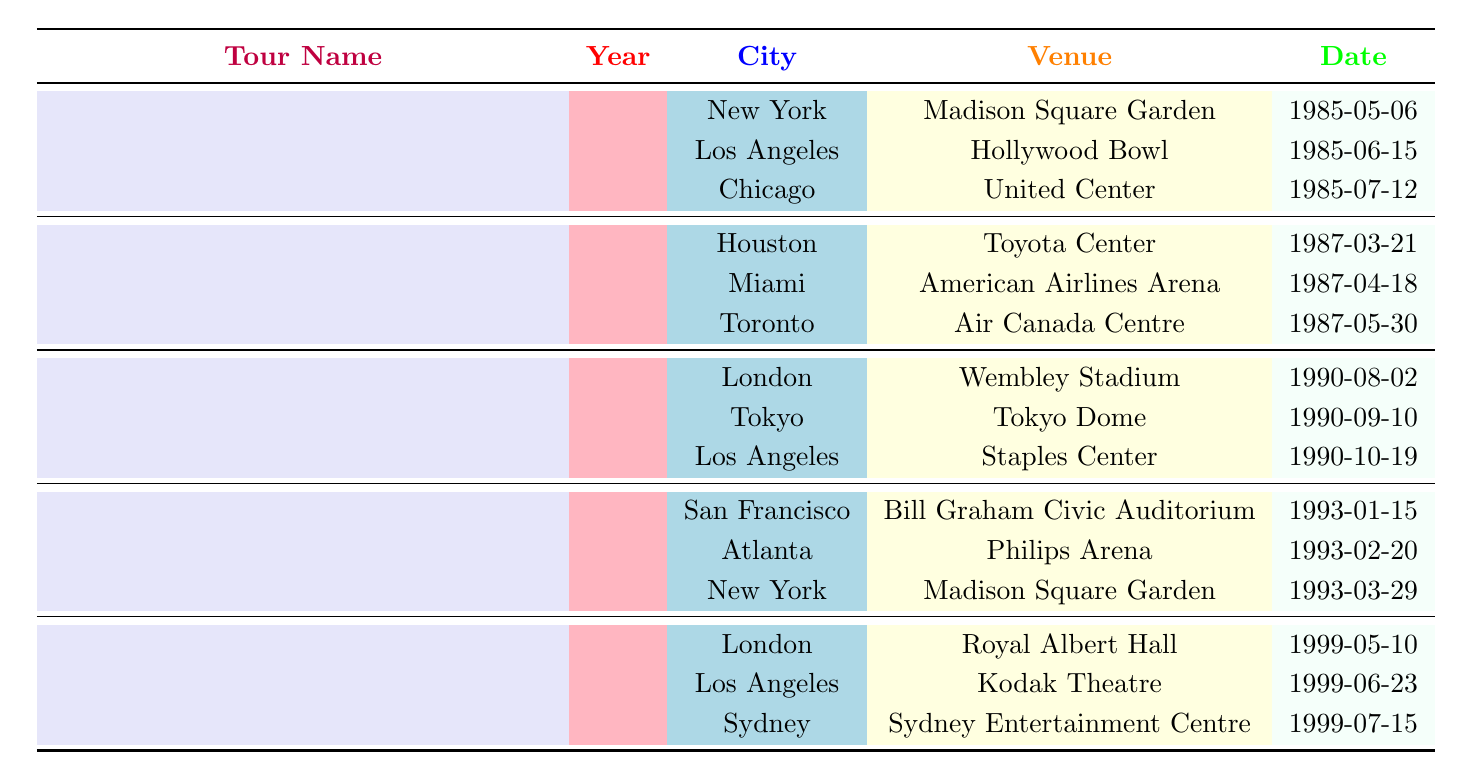What was the last tour Whitney Houston performed before 1999? The table indicates that the last tour listed is "My Love Is Your Love Tour" from the year 1999.
Answer: My Love Is Your Love Tour Which venue in New York hosted two concerts? The table shows that both "The Greatest Love Tour" and "The Bodyguard Tour" were held at Madison Square Garden in New York.
Answer: Madison Square Garden How many different cities hosted Whitney Houston concerts in 1985? In 1985, Whitney Houston performed in New York, Los Angeles, and Chicago, totaling three different cities.
Answer: 3 Did Whitney Houston ever perform in Tokyo? According to the table, she performed in Tokyo during the "I'm Your Baby Tonight World Tour" in 1990.
Answer: Yes Which concert tour had a performance in Atlanta? The "Bodyguard Tour" is the only tour listed that had a concert in Atlanta, specifically on February 20, 1993.
Answer: The Bodyguard Tour In which year did Whitney Houston perform the most concerts according to the table? Analyzing the table shows that the years 1985, 1987, 1990, and 1993 each had 3 concerts, while 1999 also had 3, so they are tied.
Answer: 1985, 1987, 1990, 1993, 1999 How many tours were held between 1985 and 1990? From the table, we see that there are three tours during this period: "The Greatest Love Tour" (1985), "Moment of Truth Tour" (1987), and "I'm Your Baby Tonight World Tour" (1990). This totals three tours.
Answer: 3 Was the Toyota Center ever a venue for Whitney Houston? The table confirms that she performed at the Toyota Center in Houston during the "Moment of Truth Tour" in 1987.
Answer: Yes Which city did Whitney Houston perform in on June 23, 1999? According to the table, she performed in Los Angeles at the Kodak Theatre on June 23, 1999.
Answer: Los Angeles 